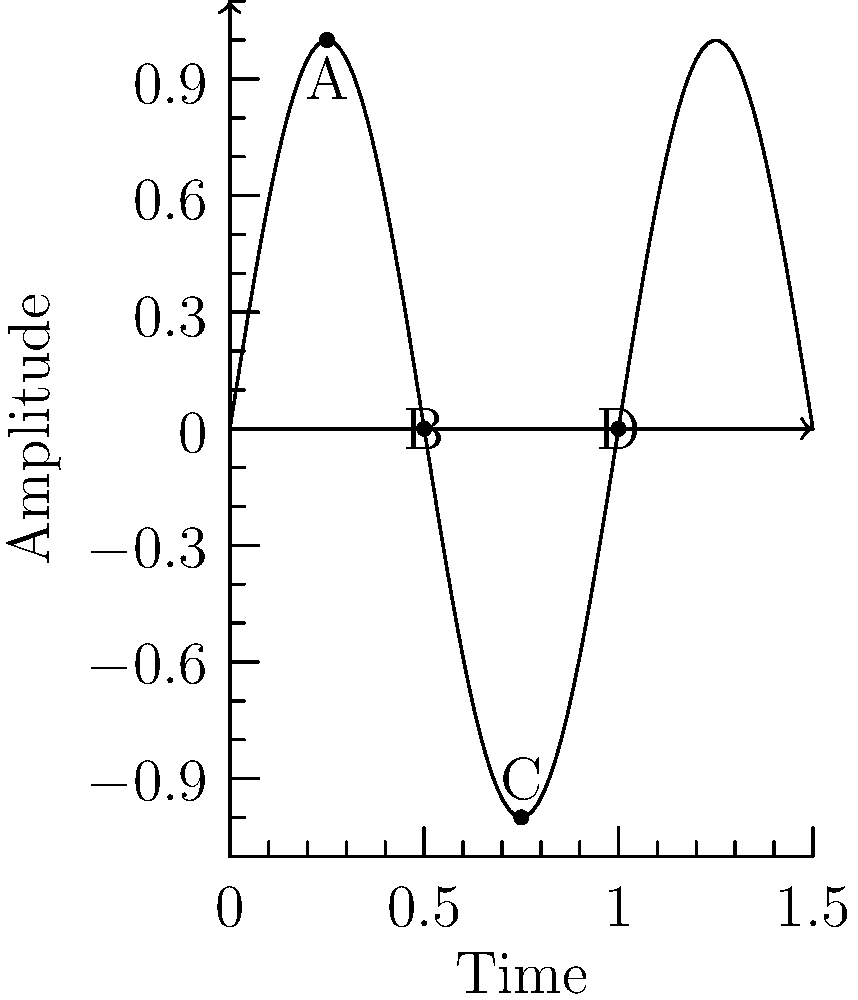As a retired musician with an ear for harmonious environments, consider this representation of a sound wave. At which point(s) would the cross-section of the wave show zero displacement from its resting position? To answer this question, we need to analyze the sound wave diagram step-by-step:

1. The graph represents a sine wave, which is a common representation of a sound wave.
2. The x-axis represents time, and the y-axis represents amplitude (displacement from the resting position).
3. The wave crosses the x-axis (zero amplitude) at regular intervals.
4. There are four labeled points on the wave:
   - Point A: At a positive peak
   - Point B: Crossing the x-axis
   - Point C: At a negative peak
   - Point D: Crossing the x-axis

5. Zero displacement from the resting position occurs when the wave crosses the x-axis.
6. Among the labeled points, B and D are on the x-axis.

Therefore, the cross-section of the wave would show zero displacement from its resting position at points B and D.
Answer: B and D 